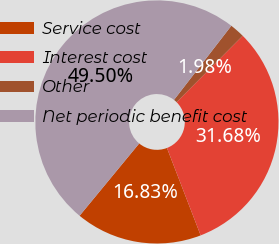Convert chart to OTSL. <chart><loc_0><loc_0><loc_500><loc_500><pie_chart><fcel>Service cost<fcel>Interest cost<fcel>Other<fcel>Net periodic benefit cost<nl><fcel>16.83%<fcel>31.68%<fcel>1.98%<fcel>49.5%<nl></chart> 